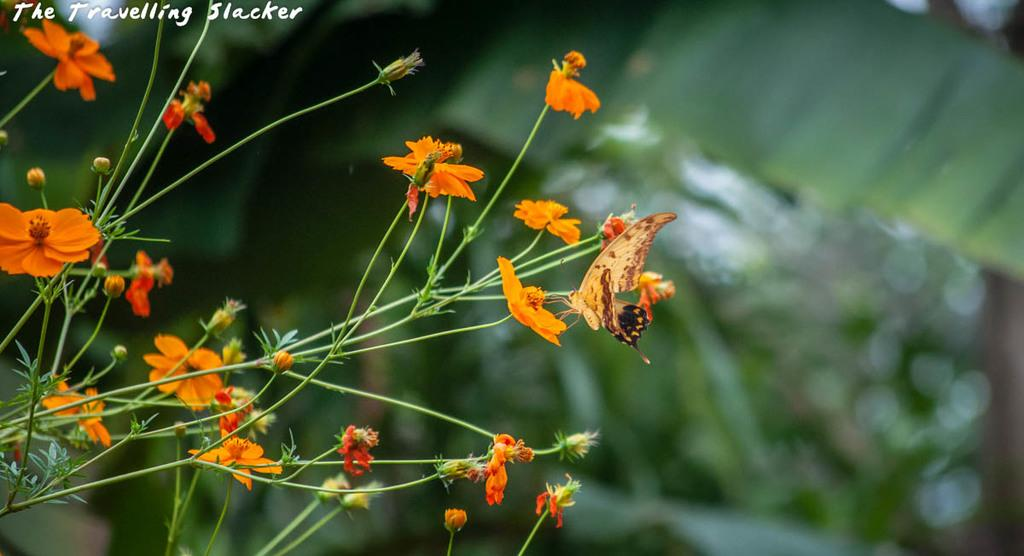What type of plant is on the left side of the image? There is a plant with flowers on the left side of the image. What is on one of the flowers? There is a butterfly on one of the flowers. Can you describe the background of the image? The background of the image is blurred. What color are the leaves visible in the background? Green leaves are visible in the background. What type of lock is holding the rose in the image? There is no lock or rose present in the image. 